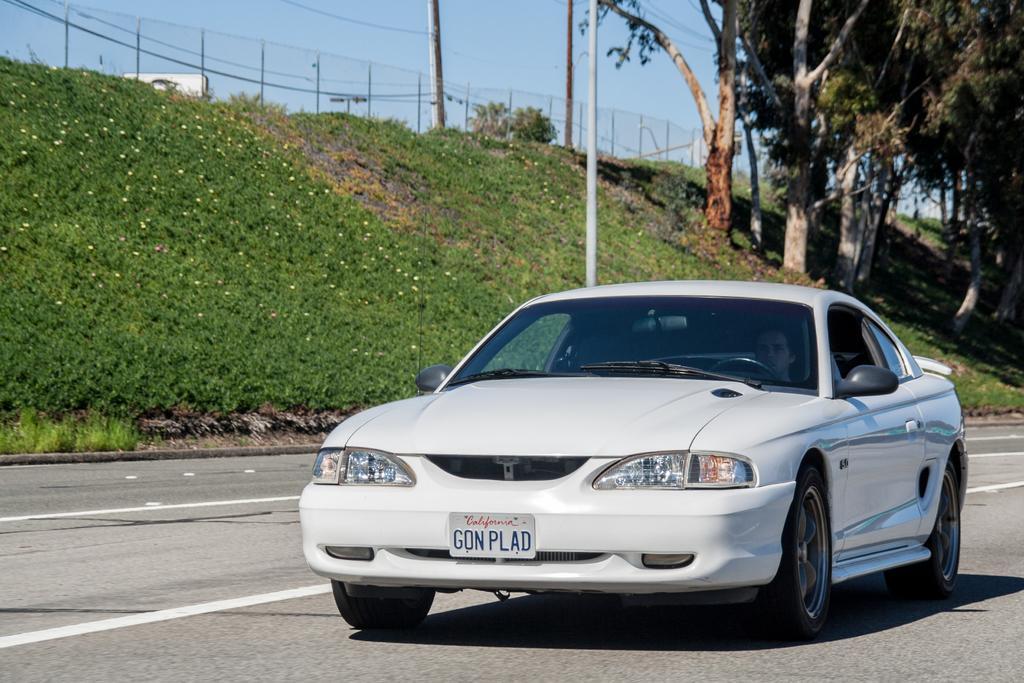Describe this image in one or two sentences. This image consists of a car in white color. At the bottom, there is a road. On the left, we can see the plants and green grass along with the trees. At the top, we can see a fence along with the sky. In the middle, there is a pole. 